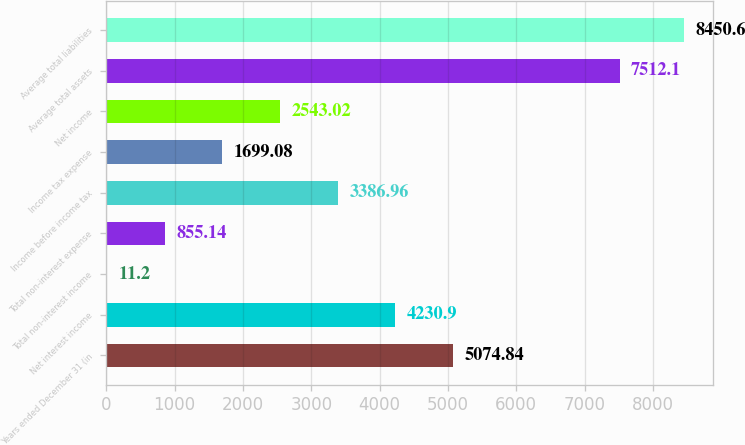Convert chart. <chart><loc_0><loc_0><loc_500><loc_500><bar_chart><fcel>Years ended December 31 (in<fcel>Net interest income<fcel>Total non-interest income<fcel>Total non-interest expense<fcel>Income before income tax<fcel>Income tax expense<fcel>Net income<fcel>Average total assets<fcel>Average total liabilities<nl><fcel>5074.84<fcel>4230.9<fcel>11.2<fcel>855.14<fcel>3386.96<fcel>1699.08<fcel>2543.02<fcel>7512.1<fcel>8450.6<nl></chart> 